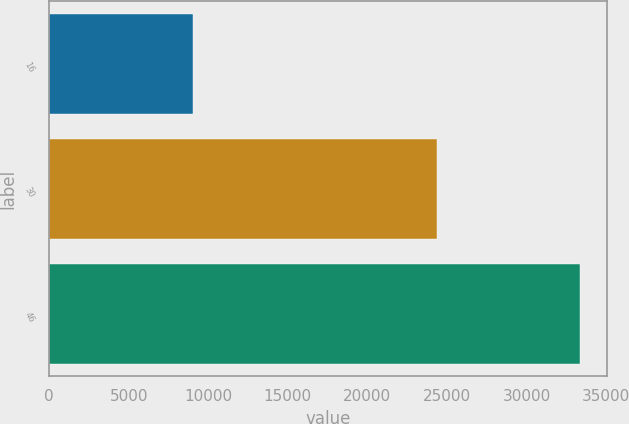Convert chart. <chart><loc_0><loc_0><loc_500><loc_500><bar_chart><fcel>16<fcel>30<fcel>46<nl><fcel>9017<fcel>24376<fcel>33393<nl></chart> 